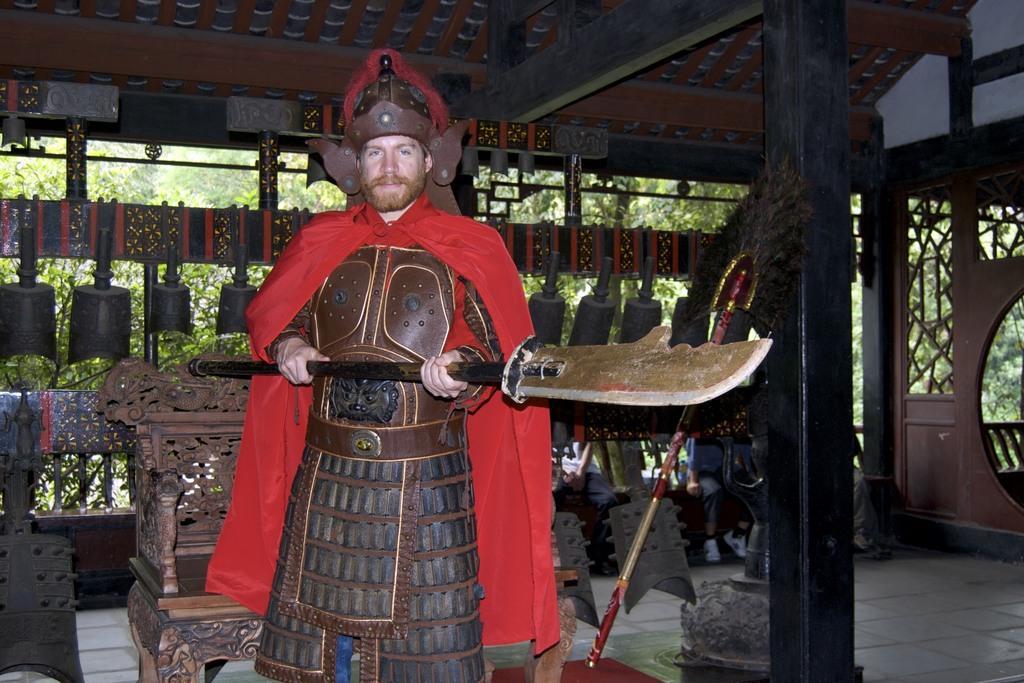In one or two sentences, can you explain what this image depicts? In the image there is a man standing and holding some object with his hand, behind him there is a chair and around the chair there are many different objects, in the background there are trees. 